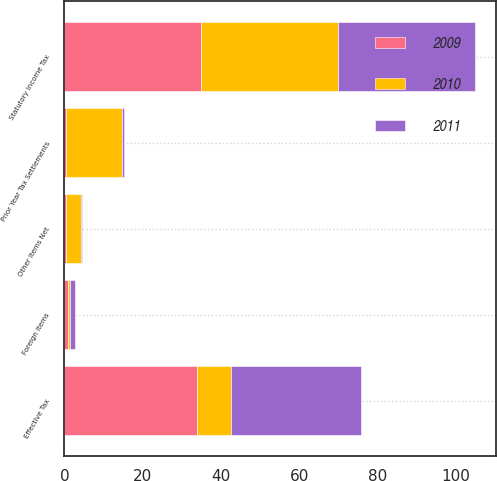Convert chart to OTSL. <chart><loc_0><loc_0><loc_500><loc_500><stacked_bar_chart><ecel><fcel>Statutory Income Tax<fcel>Prior Year Tax Settlements<fcel>Foreign Items<fcel>Other Items Net<fcel>Effective Tax<nl><fcel>2010<fcel>35<fcel>14.5<fcel>0.6<fcel>3.8<fcel>8.5<nl><fcel>2011<fcel>35<fcel>0.5<fcel>1.3<fcel>0.2<fcel>33.4<nl><fcel>2009<fcel>35<fcel>0.3<fcel>0.8<fcel>0.5<fcel>34<nl></chart> 